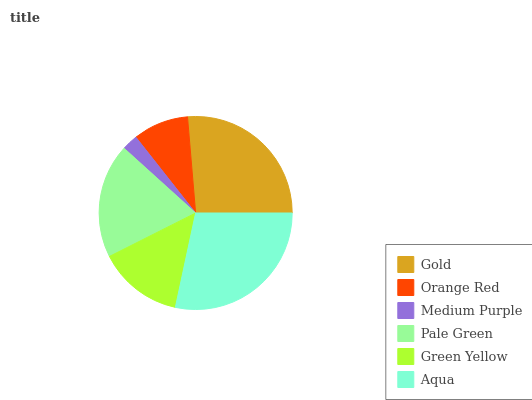Is Medium Purple the minimum?
Answer yes or no. Yes. Is Aqua the maximum?
Answer yes or no. Yes. Is Orange Red the minimum?
Answer yes or no. No. Is Orange Red the maximum?
Answer yes or no. No. Is Gold greater than Orange Red?
Answer yes or no. Yes. Is Orange Red less than Gold?
Answer yes or no. Yes. Is Orange Red greater than Gold?
Answer yes or no. No. Is Gold less than Orange Red?
Answer yes or no. No. Is Pale Green the high median?
Answer yes or no. Yes. Is Green Yellow the low median?
Answer yes or no. Yes. Is Medium Purple the high median?
Answer yes or no. No. Is Medium Purple the low median?
Answer yes or no. No. 